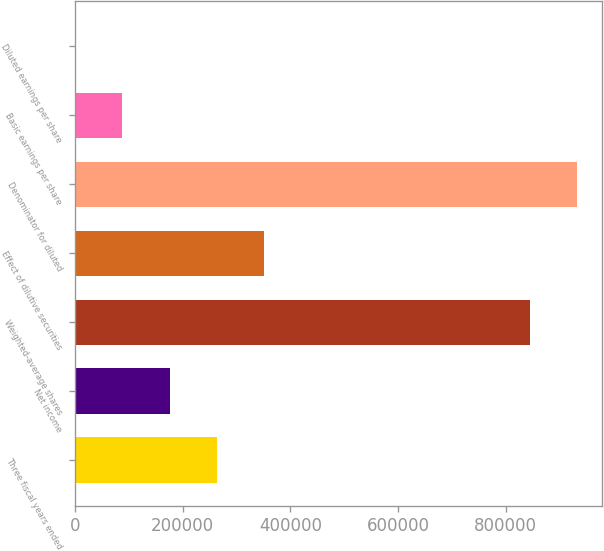<chart> <loc_0><loc_0><loc_500><loc_500><bar_chart><fcel>Three fiscal years ended<fcel>Net income<fcel>Weighted-average shares<fcel>Effect of dilutive securities<fcel>Denominator for diluted<fcel>Basic earnings per share<fcel>Diluted earnings per share<nl><fcel>263259<fcel>175507<fcel>844058<fcel>351012<fcel>931810<fcel>87754.6<fcel>2.27<nl></chart> 